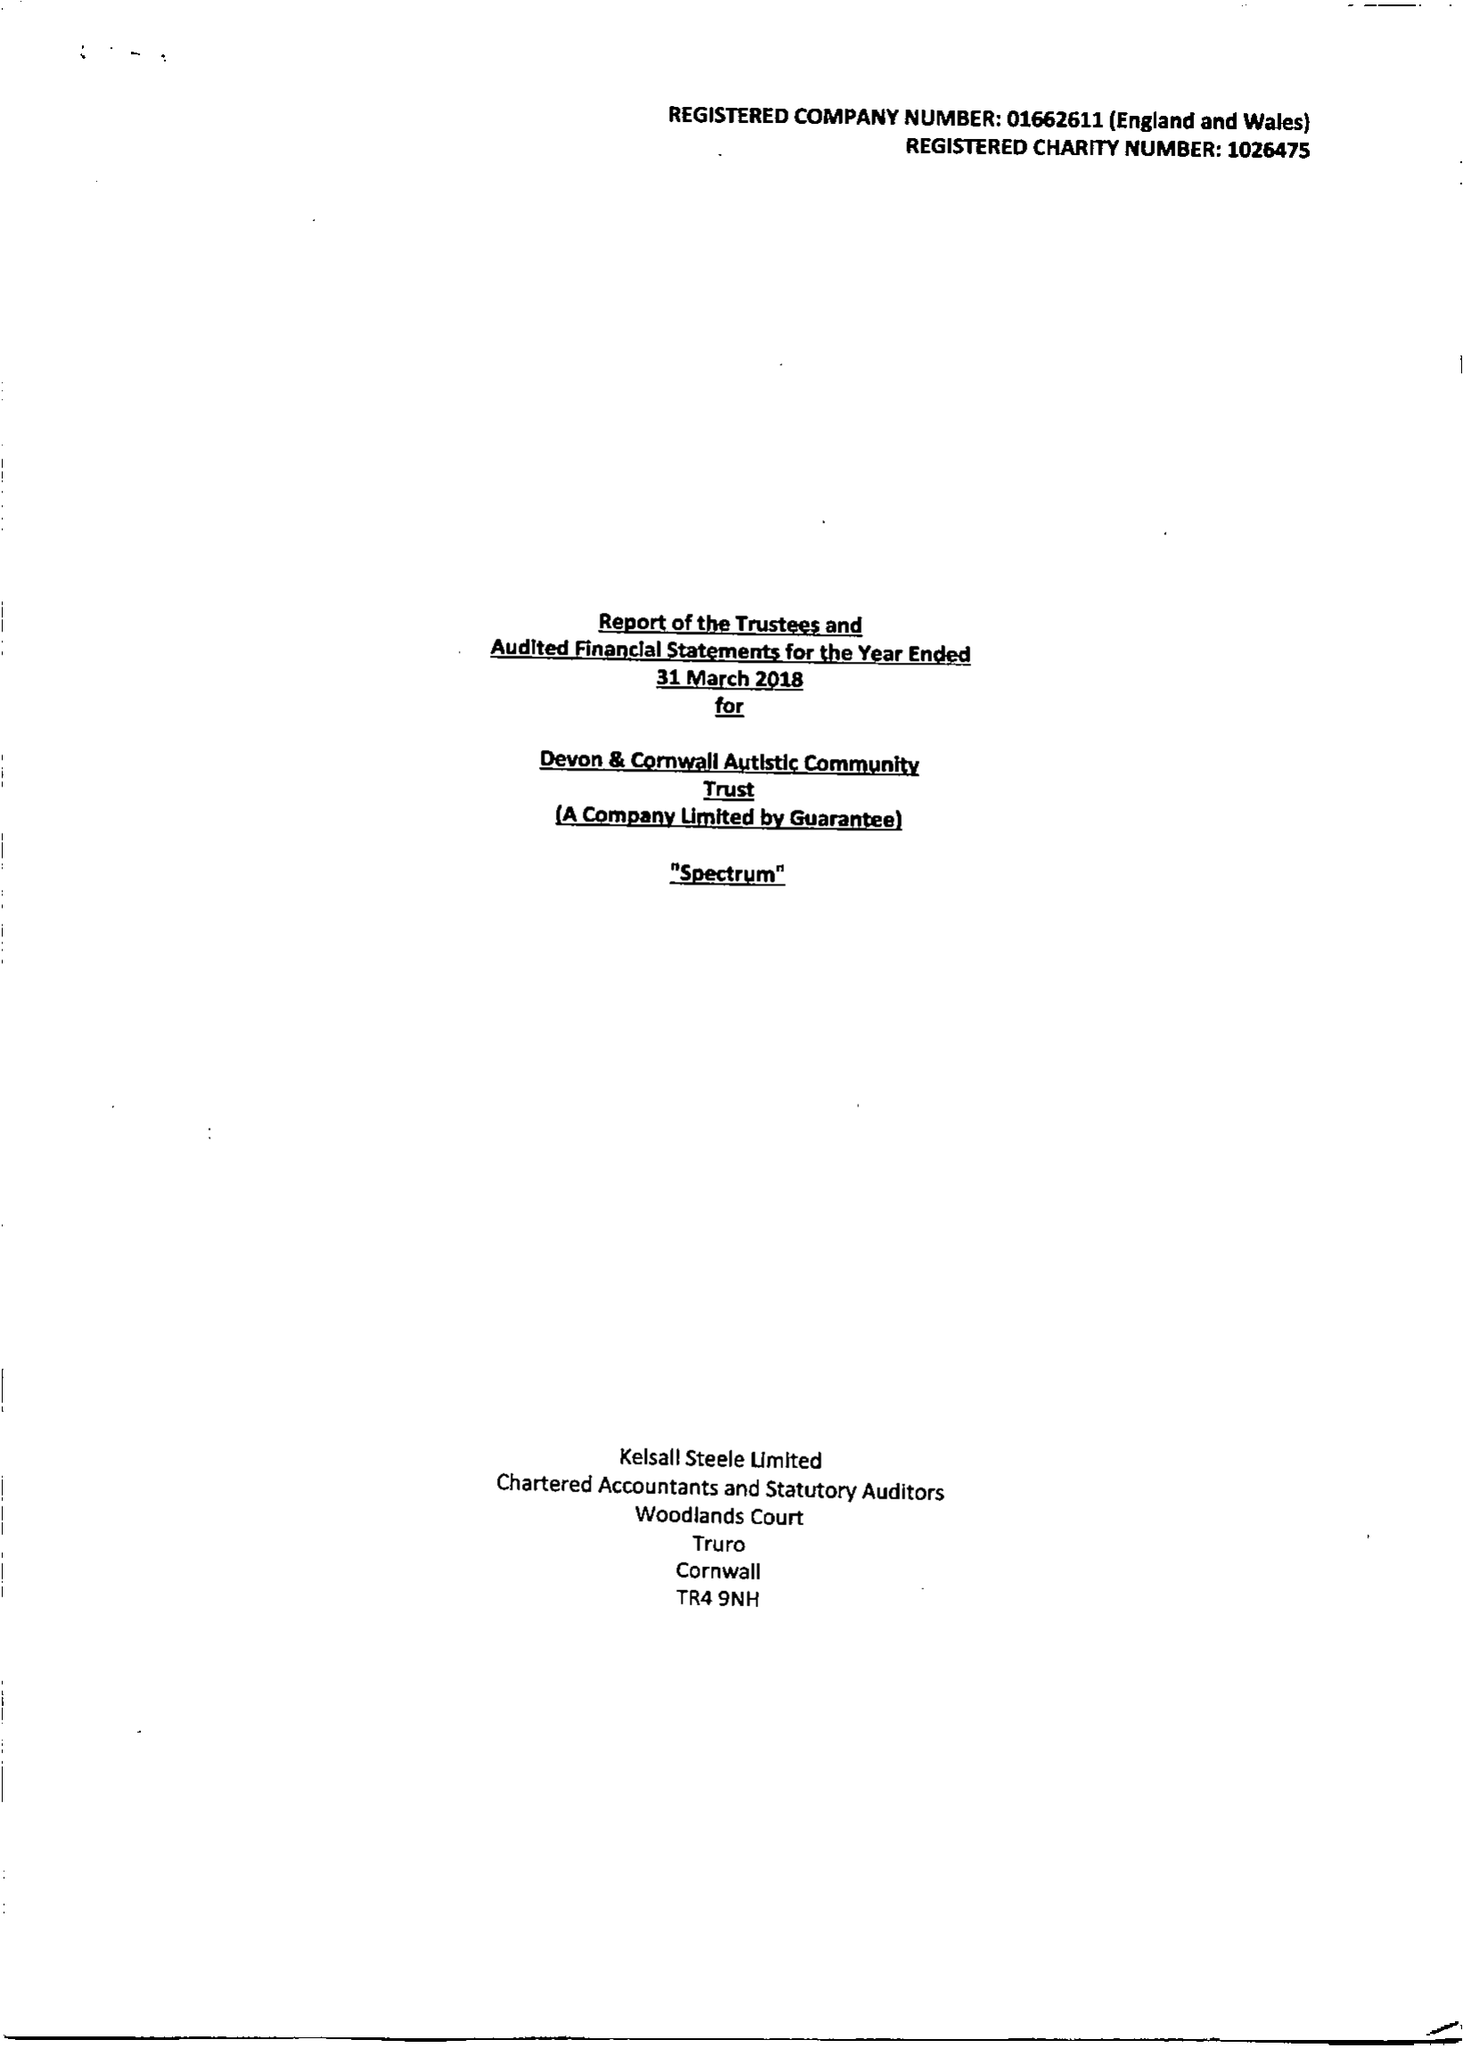What is the value for the address__post_town?
Answer the question using a single word or phrase. HELSTON 